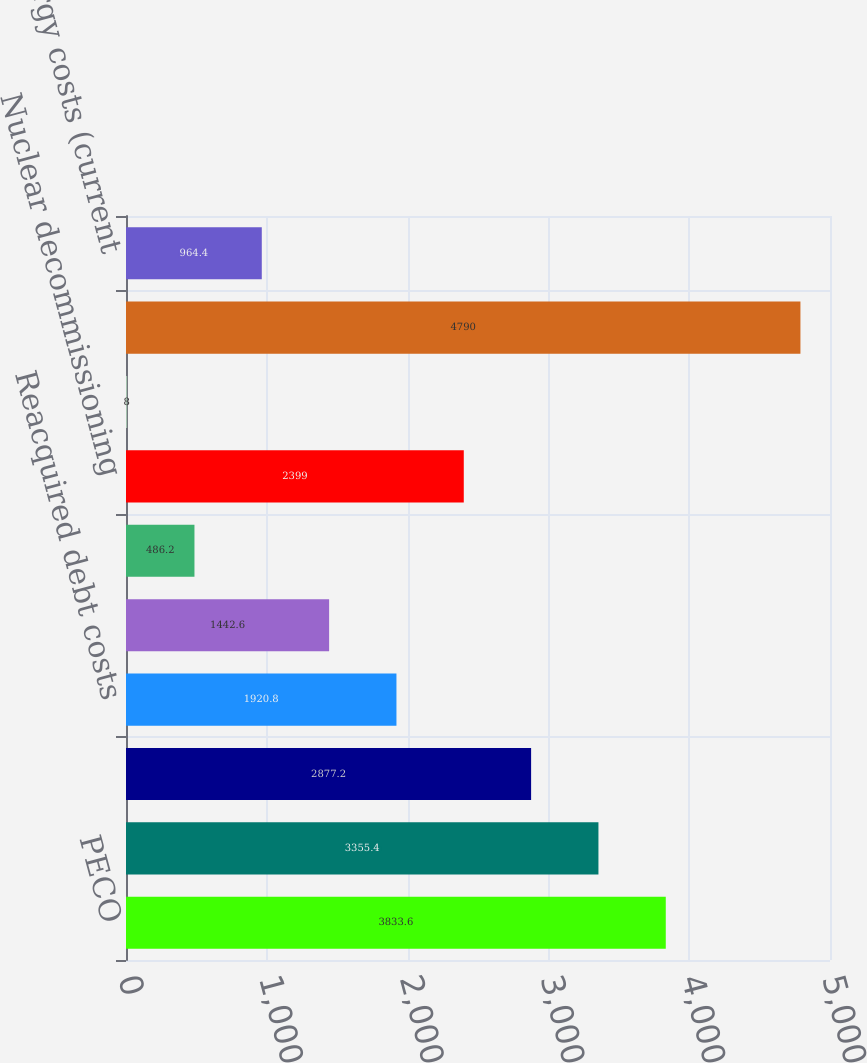<chart> <loc_0><loc_0><loc_500><loc_500><bar_chart><fcel>PECO<fcel>Deferred income taxes<fcel>Non-pension postretirement<fcel>Reacquired debt costs<fcel>MGP regulatory asset<fcel>DOE facility decommissioning<fcel>Nuclear decommissioning<fcel>Other<fcel>Long-term regulatory assets<fcel>Deferred energy costs (current<nl><fcel>3833.6<fcel>3355.4<fcel>2877.2<fcel>1920.8<fcel>1442.6<fcel>486.2<fcel>2399<fcel>8<fcel>4790<fcel>964.4<nl></chart> 